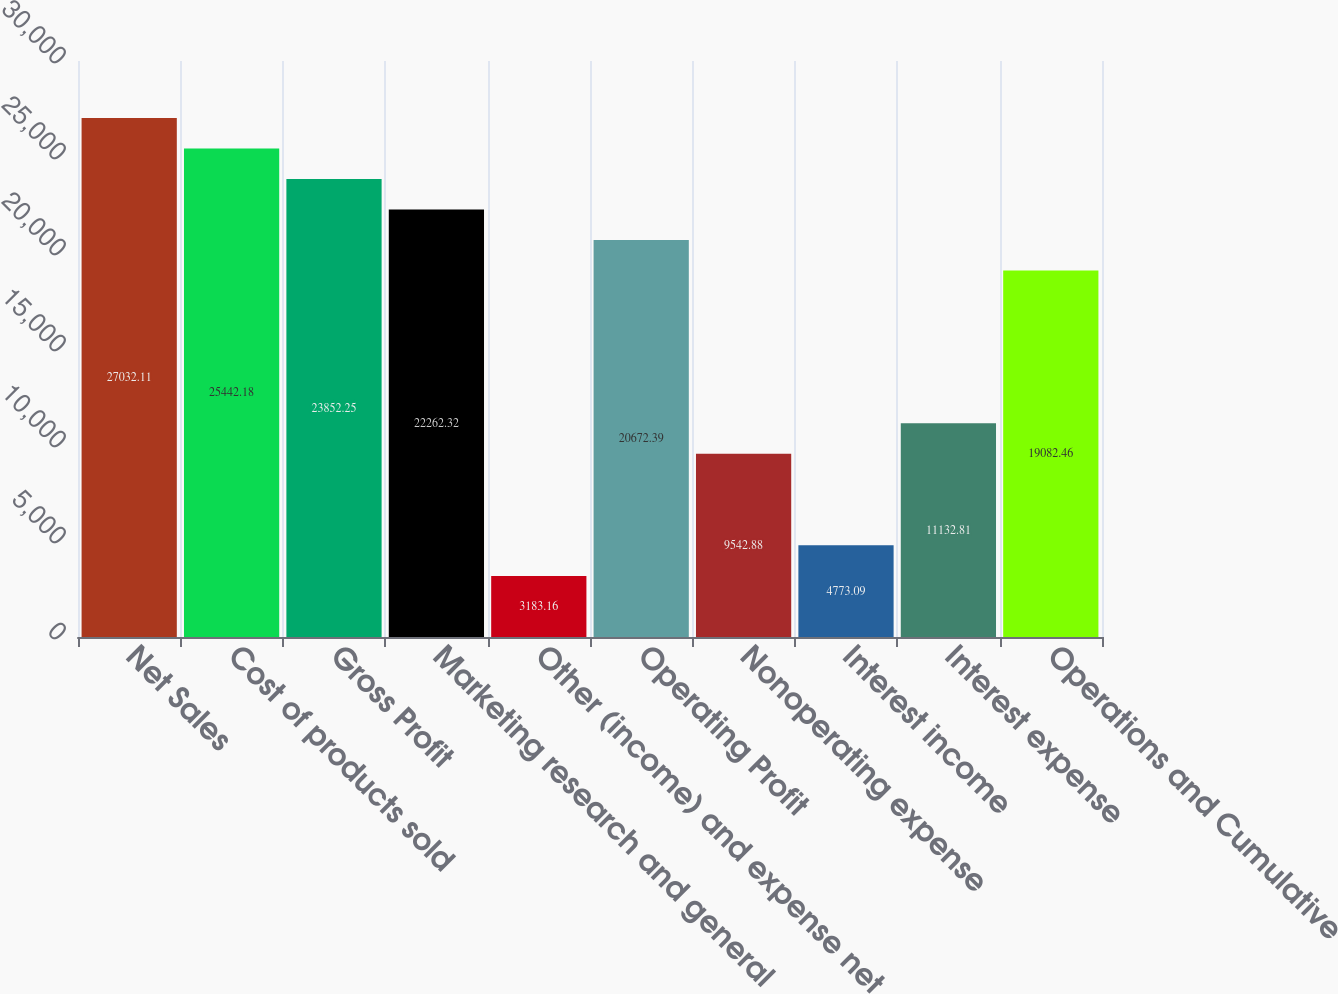Convert chart. <chart><loc_0><loc_0><loc_500><loc_500><bar_chart><fcel>Net Sales<fcel>Cost of products sold<fcel>Gross Profit<fcel>Marketing research and general<fcel>Other (income) and expense net<fcel>Operating Profit<fcel>Nonoperating expense<fcel>Interest income<fcel>Interest expense<fcel>Operations and Cumulative<nl><fcel>27032.1<fcel>25442.2<fcel>23852.2<fcel>22262.3<fcel>3183.16<fcel>20672.4<fcel>9542.88<fcel>4773.09<fcel>11132.8<fcel>19082.5<nl></chart> 